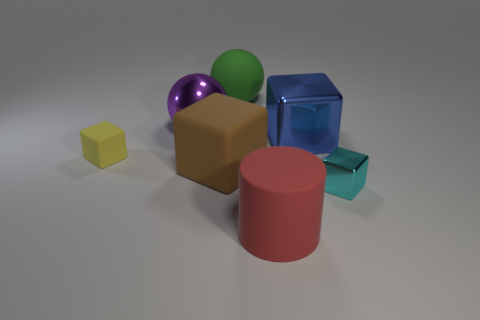Subtract 1 cubes. How many cubes are left? 3 Add 2 large cylinders. How many objects exist? 9 Subtract all yellow rubber cubes. How many cubes are left? 3 Subtract all purple spheres. How many spheres are left? 1 Subtract all tiny green matte cylinders. Subtract all large shiny spheres. How many objects are left? 6 Add 4 small yellow blocks. How many small yellow blocks are left? 5 Add 2 big red rubber cylinders. How many big red rubber cylinders exist? 3 Subtract 1 blue cubes. How many objects are left? 6 Subtract all cylinders. How many objects are left? 6 Subtract all purple blocks. Subtract all blue cylinders. How many blocks are left? 4 